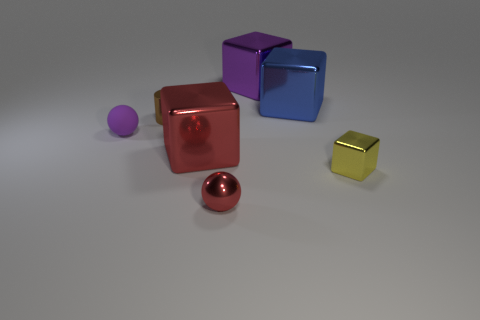Can you describe the texture or finish on the objects? Certainly! The objects appear to have a metallic finish, evident by the reflective surfaces and smoothed edges. The lighting in the image creates highlights and shadows that give the objects a glossy, realistic texture. 